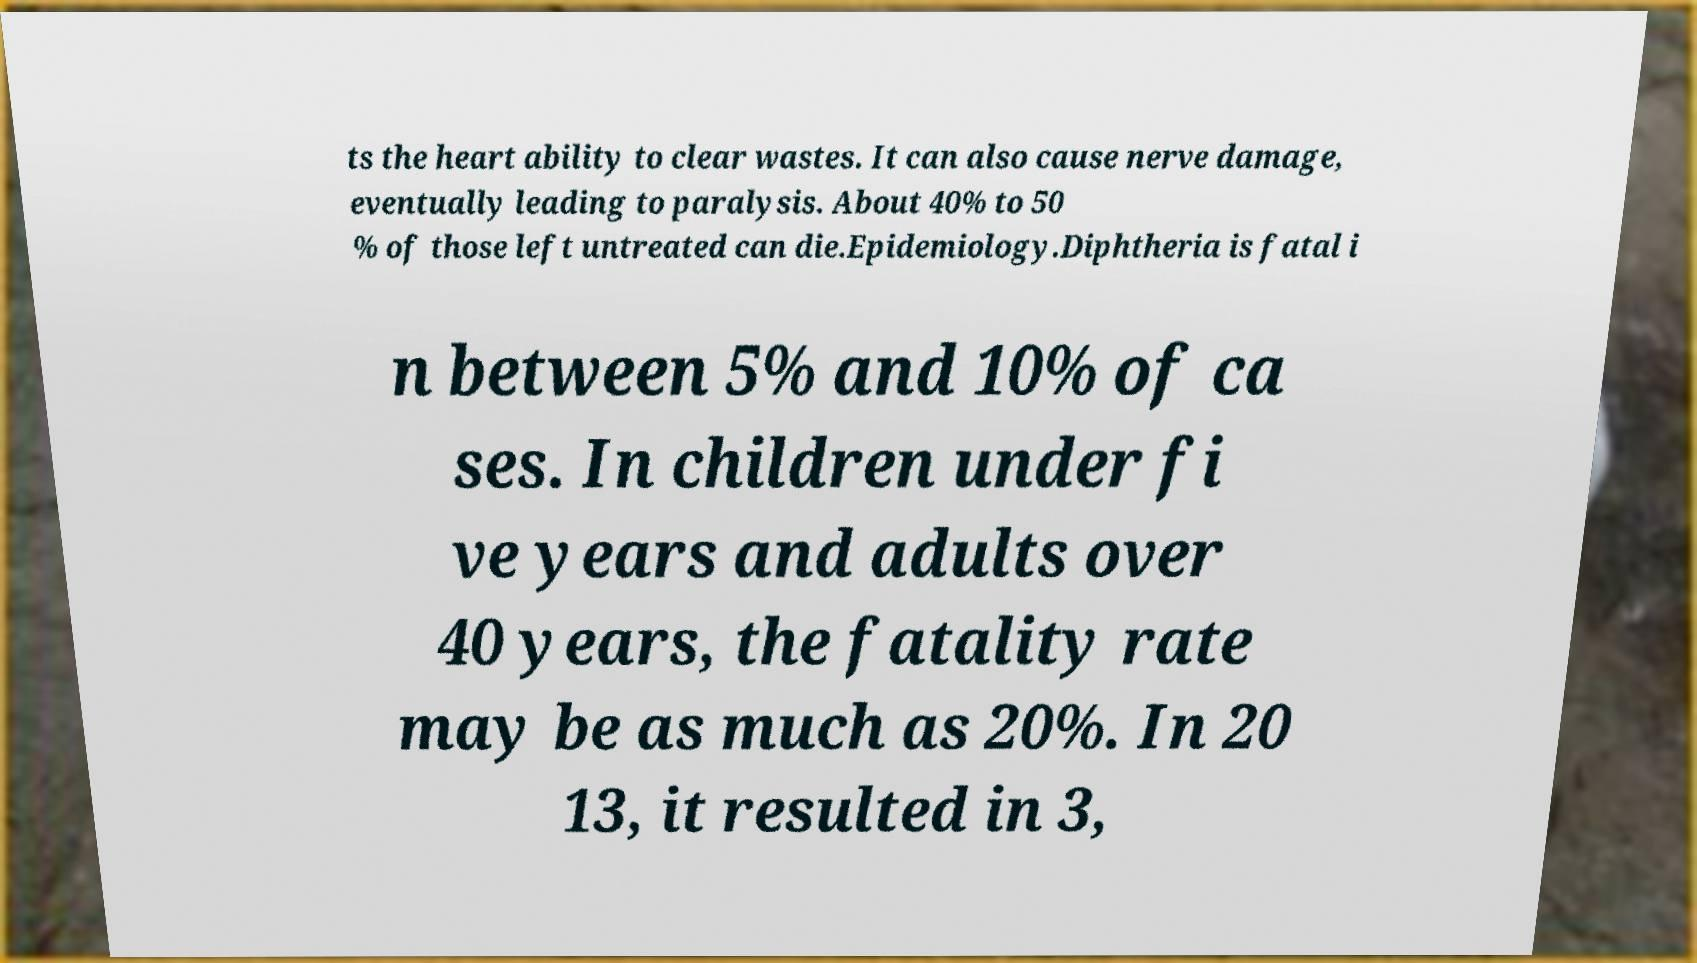Please read and relay the text visible in this image. What does it say? ts the heart ability to clear wastes. It can also cause nerve damage, eventually leading to paralysis. About 40% to 50 % of those left untreated can die.Epidemiology.Diphtheria is fatal i n between 5% and 10% of ca ses. In children under fi ve years and adults over 40 years, the fatality rate may be as much as 20%. In 20 13, it resulted in 3, 